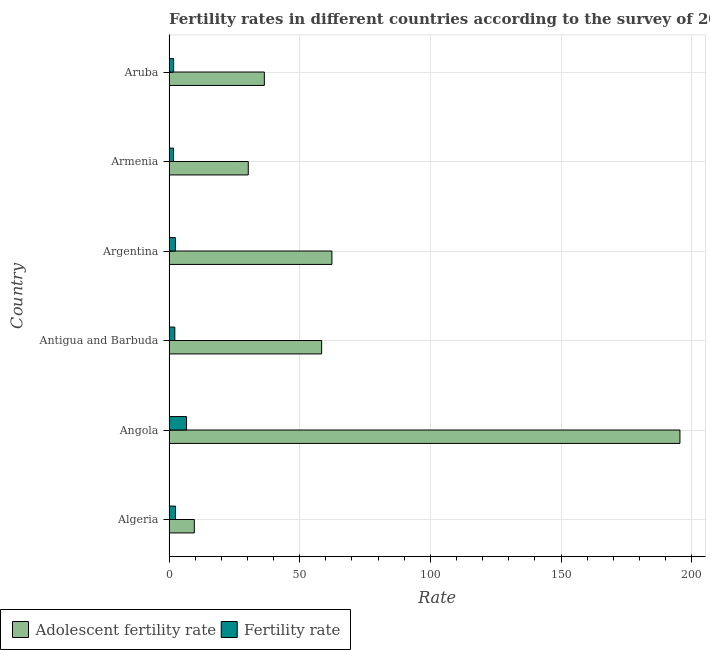Are the number of bars per tick equal to the number of legend labels?
Your answer should be compact. Yes. How many bars are there on the 1st tick from the top?
Ensure brevity in your answer.  2. How many bars are there on the 5th tick from the bottom?
Ensure brevity in your answer.  2. What is the label of the 6th group of bars from the top?
Offer a terse response. Algeria. What is the adolescent fertility rate in Antigua and Barbuda?
Provide a succinct answer. 58.41. Across all countries, what is the maximum adolescent fertility rate?
Your answer should be compact. 195.51. Across all countries, what is the minimum adolescent fertility rate?
Ensure brevity in your answer.  9.68. In which country was the fertility rate maximum?
Give a very brief answer. Angola. In which country was the fertility rate minimum?
Offer a terse response. Armenia. What is the total adolescent fertility rate in the graph?
Offer a terse response. 392.76. What is the difference between the adolescent fertility rate in Angola and that in Aruba?
Offer a terse response. 159.03. What is the difference between the fertility rate in Argentina and the adolescent fertility rate in Algeria?
Provide a short and direct response. -7.23. What is the average adolescent fertility rate per country?
Make the answer very short. 65.46. What is the difference between the fertility rate and adolescent fertility rate in Antigua and Barbuda?
Give a very brief answer. -56.18. In how many countries, is the fertility rate greater than 10 ?
Offer a terse response. 0. What is the ratio of the adolescent fertility rate in Algeria to that in Angola?
Provide a short and direct response. 0.05. Is the difference between the fertility rate in Algeria and Argentina greater than the difference between the adolescent fertility rate in Algeria and Argentina?
Provide a short and direct response. Yes. What is the difference between the highest and the second highest adolescent fertility rate?
Ensure brevity in your answer.  133.18. What is the difference between the highest and the lowest fertility rate?
Give a very brief answer. 4.98. Is the sum of the fertility rate in Algeria and Angola greater than the maximum adolescent fertility rate across all countries?
Ensure brevity in your answer.  No. What does the 1st bar from the top in Argentina represents?
Provide a short and direct response. Fertility rate. What does the 2nd bar from the bottom in Antigua and Barbuda represents?
Keep it short and to the point. Fertility rate. Are all the bars in the graph horizontal?
Keep it short and to the point. Yes. How many countries are there in the graph?
Keep it short and to the point. 6. What is the difference between two consecutive major ticks on the X-axis?
Make the answer very short. 50. Where does the legend appear in the graph?
Your answer should be compact. Bottom left. How are the legend labels stacked?
Offer a very short reply. Horizontal. What is the title of the graph?
Give a very brief answer. Fertility rates in different countries according to the survey of 2005. What is the label or title of the X-axis?
Keep it short and to the point. Rate. What is the label or title of the Y-axis?
Offer a terse response. Country. What is the Rate of Adolescent fertility rate in Algeria?
Provide a succinct answer. 9.68. What is the Rate in Fertility rate in Algeria?
Your answer should be very brief. 2.5. What is the Rate in Adolescent fertility rate in Angola?
Keep it short and to the point. 195.51. What is the Rate of Fertility rate in Angola?
Offer a terse response. 6.72. What is the Rate of Adolescent fertility rate in Antigua and Barbuda?
Offer a very short reply. 58.41. What is the Rate in Fertility rate in Antigua and Barbuda?
Provide a short and direct response. 2.22. What is the Rate in Adolescent fertility rate in Argentina?
Your answer should be compact. 62.34. What is the Rate in Fertility rate in Argentina?
Provide a short and direct response. 2.45. What is the Rate in Adolescent fertility rate in Armenia?
Keep it short and to the point. 30.33. What is the Rate of Fertility rate in Armenia?
Offer a very short reply. 1.74. What is the Rate of Adolescent fertility rate in Aruba?
Make the answer very short. 36.48. What is the Rate in Fertility rate in Aruba?
Make the answer very short. 1.77. Across all countries, what is the maximum Rate in Adolescent fertility rate?
Provide a short and direct response. 195.51. Across all countries, what is the maximum Rate of Fertility rate?
Ensure brevity in your answer.  6.72. Across all countries, what is the minimum Rate in Adolescent fertility rate?
Offer a very short reply. 9.68. Across all countries, what is the minimum Rate of Fertility rate?
Provide a short and direct response. 1.74. What is the total Rate of Adolescent fertility rate in the graph?
Make the answer very short. 392.76. What is the total Rate in Fertility rate in the graph?
Keep it short and to the point. 17.4. What is the difference between the Rate of Adolescent fertility rate in Algeria and that in Angola?
Provide a succinct answer. -185.83. What is the difference between the Rate in Fertility rate in Algeria and that in Angola?
Your answer should be compact. -4.22. What is the difference between the Rate in Adolescent fertility rate in Algeria and that in Antigua and Barbuda?
Provide a short and direct response. -48.72. What is the difference between the Rate of Fertility rate in Algeria and that in Antigua and Barbuda?
Make the answer very short. 0.28. What is the difference between the Rate of Adolescent fertility rate in Algeria and that in Argentina?
Provide a succinct answer. -52.65. What is the difference between the Rate in Fertility rate in Algeria and that in Argentina?
Provide a short and direct response. 0.05. What is the difference between the Rate in Adolescent fertility rate in Algeria and that in Armenia?
Make the answer very short. -20.65. What is the difference between the Rate in Fertility rate in Algeria and that in Armenia?
Your answer should be compact. 0.76. What is the difference between the Rate of Adolescent fertility rate in Algeria and that in Aruba?
Provide a succinct answer. -26.8. What is the difference between the Rate in Fertility rate in Algeria and that in Aruba?
Make the answer very short. 0.73. What is the difference between the Rate of Adolescent fertility rate in Angola and that in Antigua and Barbuda?
Provide a succinct answer. 137.1. What is the difference between the Rate in Fertility rate in Angola and that in Antigua and Barbuda?
Offer a terse response. 4.49. What is the difference between the Rate in Adolescent fertility rate in Angola and that in Argentina?
Offer a terse response. 133.18. What is the difference between the Rate in Fertility rate in Angola and that in Argentina?
Your response must be concise. 4.26. What is the difference between the Rate of Adolescent fertility rate in Angola and that in Armenia?
Provide a short and direct response. 165.18. What is the difference between the Rate in Fertility rate in Angola and that in Armenia?
Your answer should be compact. 4.98. What is the difference between the Rate of Adolescent fertility rate in Angola and that in Aruba?
Your answer should be very brief. 159.03. What is the difference between the Rate in Fertility rate in Angola and that in Aruba?
Give a very brief answer. 4.95. What is the difference between the Rate of Adolescent fertility rate in Antigua and Barbuda and that in Argentina?
Your answer should be very brief. -3.93. What is the difference between the Rate in Fertility rate in Antigua and Barbuda and that in Argentina?
Give a very brief answer. -0.23. What is the difference between the Rate of Adolescent fertility rate in Antigua and Barbuda and that in Armenia?
Give a very brief answer. 28.08. What is the difference between the Rate in Fertility rate in Antigua and Barbuda and that in Armenia?
Your answer should be very brief. 0.49. What is the difference between the Rate in Adolescent fertility rate in Antigua and Barbuda and that in Aruba?
Ensure brevity in your answer.  21.92. What is the difference between the Rate of Fertility rate in Antigua and Barbuda and that in Aruba?
Offer a very short reply. 0.45. What is the difference between the Rate of Adolescent fertility rate in Argentina and that in Armenia?
Offer a terse response. 32.01. What is the difference between the Rate in Fertility rate in Argentina and that in Armenia?
Ensure brevity in your answer.  0.71. What is the difference between the Rate in Adolescent fertility rate in Argentina and that in Aruba?
Keep it short and to the point. 25.85. What is the difference between the Rate in Fertility rate in Argentina and that in Aruba?
Ensure brevity in your answer.  0.68. What is the difference between the Rate in Adolescent fertility rate in Armenia and that in Aruba?
Make the answer very short. -6.15. What is the difference between the Rate in Fertility rate in Armenia and that in Aruba?
Offer a terse response. -0.03. What is the difference between the Rate in Adolescent fertility rate in Algeria and the Rate in Fertility rate in Angola?
Keep it short and to the point. 2.97. What is the difference between the Rate in Adolescent fertility rate in Algeria and the Rate in Fertility rate in Antigua and Barbuda?
Make the answer very short. 7.46. What is the difference between the Rate in Adolescent fertility rate in Algeria and the Rate in Fertility rate in Argentina?
Provide a short and direct response. 7.23. What is the difference between the Rate of Adolescent fertility rate in Algeria and the Rate of Fertility rate in Armenia?
Offer a very short reply. 7.95. What is the difference between the Rate in Adolescent fertility rate in Algeria and the Rate in Fertility rate in Aruba?
Offer a terse response. 7.91. What is the difference between the Rate of Adolescent fertility rate in Angola and the Rate of Fertility rate in Antigua and Barbuda?
Ensure brevity in your answer.  193.29. What is the difference between the Rate in Adolescent fertility rate in Angola and the Rate in Fertility rate in Argentina?
Your answer should be compact. 193.06. What is the difference between the Rate of Adolescent fertility rate in Angola and the Rate of Fertility rate in Armenia?
Your answer should be compact. 193.78. What is the difference between the Rate in Adolescent fertility rate in Angola and the Rate in Fertility rate in Aruba?
Your answer should be compact. 193.74. What is the difference between the Rate of Adolescent fertility rate in Antigua and Barbuda and the Rate of Fertility rate in Argentina?
Offer a terse response. 55.96. What is the difference between the Rate of Adolescent fertility rate in Antigua and Barbuda and the Rate of Fertility rate in Armenia?
Offer a terse response. 56.67. What is the difference between the Rate of Adolescent fertility rate in Antigua and Barbuda and the Rate of Fertility rate in Aruba?
Provide a succinct answer. 56.64. What is the difference between the Rate of Adolescent fertility rate in Argentina and the Rate of Fertility rate in Armenia?
Provide a short and direct response. 60.6. What is the difference between the Rate of Adolescent fertility rate in Argentina and the Rate of Fertility rate in Aruba?
Give a very brief answer. 60.57. What is the difference between the Rate of Adolescent fertility rate in Armenia and the Rate of Fertility rate in Aruba?
Your response must be concise. 28.56. What is the average Rate of Adolescent fertility rate per country?
Provide a short and direct response. 65.46. What is the average Rate in Fertility rate per country?
Provide a succinct answer. 2.9. What is the difference between the Rate of Adolescent fertility rate and Rate of Fertility rate in Algeria?
Your answer should be very brief. 7.19. What is the difference between the Rate in Adolescent fertility rate and Rate in Fertility rate in Angola?
Keep it short and to the point. 188.8. What is the difference between the Rate of Adolescent fertility rate and Rate of Fertility rate in Antigua and Barbuda?
Keep it short and to the point. 56.18. What is the difference between the Rate of Adolescent fertility rate and Rate of Fertility rate in Argentina?
Your answer should be compact. 59.88. What is the difference between the Rate in Adolescent fertility rate and Rate in Fertility rate in Armenia?
Your answer should be compact. 28.59. What is the difference between the Rate of Adolescent fertility rate and Rate of Fertility rate in Aruba?
Keep it short and to the point. 34.71. What is the ratio of the Rate in Adolescent fertility rate in Algeria to that in Angola?
Give a very brief answer. 0.05. What is the ratio of the Rate of Fertility rate in Algeria to that in Angola?
Ensure brevity in your answer.  0.37. What is the ratio of the Rate of Adolescent fertility rate in Algeria to that in Antigua and Barbuda?
Give a very brief answer. 0.17. What is the ratio of the Rate of Fertility rate in Algeria to that in Antigua and Barbuda?
Your answer should be compact. 1.12. What is the ratio of the Rate of Adolescent fertility rate in Algeria to that in Argentina?
Provide a succinct answer. 0.16. What is the ratio of the Rate in Fertility rate in Algeria to that in Argentina?
Make the answer very short. 1.02. What is the ratio of the Rate of Adolescent fertility rate in Algeria to that in Armenia?
Your response must be concise. 0.32. What is the ratio of the Rate in Fertility rate in Algeria to that in Armenia?
Your answer should be very brief. 1.44. What is the ratio of the Rate of Adolescent fertility rate in Algeria to that in Aruba?
Your answer should be compact. 0.27. What is the ratio of the Rate of Fertility rate in Algeria to that in Aruba?
Offer a terse response. 1.41. What is the ratio of the Rate in Adolescent fertility rate in Angola to that in Antigua and Barbuda?
Provide a short and direct response. 3.35. What is the ratio of the Rate in Fertility rate in Angola to that in Antigua and Barbuda?
Give a very brief answer. 3.02. What is the ratio of the Rate of Adolescent fertility rate in Angola to that in Argentina?
Make the answer very short. 3.14. What is the ratio of the Rate in Fertility rate in Angola to that in Argentina?
Offer a terse response. 2.74. What is the ratio of the Rate of Adolescent fertility rate in Angola to that in Armenia?
Your answer should be very brief. 6.45. What is the ratio of the Rate in Fertility rate in Angola to that in Armenia?
Keep it short and to the point. 3.87. What is the ratio of the Rate in Adolescent fertility rate in Angola to that in Aruba?
Offer a very short reply. 5.36. What is the ratio of the Rate in Fertility rate in Angola to that in Aruba?
Ensure brevity in your answer.  3.79. What is the ratio of the Rate of Adolescent fertility rate in Antigua and Barbuda to that in Argentina?
Offer a very short reply. 0.94. What is the ratio of the Rate in Fertility rate in Antigua and Barbuda to that in Argentina?
Give a very brief answer. 0.91. What is the ratio of the Rate in Adolescent fertility rate in Antigua and Barbuda to that in Armenia?
Offer a very short reply. 1.93. What is the ratio of the Rate in Fertility rate in Antigua and Barbuda to that in Armenia?
Your answer should be very brief. 1.28. What is the ratio of the Rate of Adolescent fertility rate in Antigua and Barbuda to that in Aruba?
Your answer should be compact. 1.6. What is the ratio of the Rate in Fertility rate in Antigua and Barbuda to that in Aruba?
Keep it short and to the point. 1.26. What is the ratio of the Rate in Adolescent fertility rate in Argentina to that in Armenia?
Provide a succinct answer. 2.06. What is the ratio of the Rate in Fertility rate in Argentina to that in Armenia?
Offer a terse response. 1.41. What is the ratio of the Rate in Adolescent fertility rate in Argentina to that in Aruba?
Provide a succinct answer. 1.71. What is the ratio of the Rate of Fertility rate in Argentina to that in Aruba?
Provide a succinct answer. 1.39. What is the ratio of the Rate of Adolescent fertility rate in Armenia to that in Aruba?
Your response must be concise. 0.83. What is the ratio of the Rate in Fertility rate in Armenia to that in Aruba?
Offer a very short reply. 0.98. What is the difference between the highest and the second highest Rate of Adolescent fertility rate?
Offer a very short reply. 133.18. What is the difference between the highest and the second highest Rate in Fertility rate?
Ensure brevity in your answer.  4.22. What is the difference between the highest and the lowest Rate of Adolescent fertility rate?
Provide a succinct answer. 185.83. What is the difference between the highest and the lowest Rate of Fertility rate?
Offer a very short reply. 4.98. 